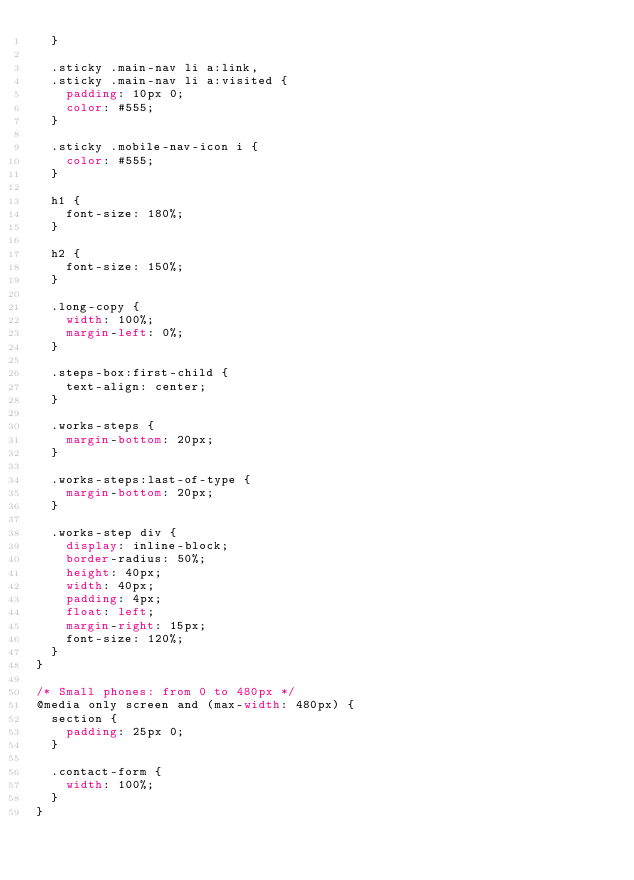<code> <loc_0><loc_0><loc_500><loc_500><_CSS_>  }

  .sticky .main-nav li a:link,
  .sticky .main-nav li a:visited {
    padding: 10px 0;
    color: #555;
  }

  .sticky .mobile-nav-icon i {
    color: #555;
  }

  h1 {
    font-size: 180%;
  }

  h2 {
    font-size: 150%;
  }

  .long-copy {
    width: 100%;
    margin-left: 0%;
  }

  .steps-box:first-child {
    text-align: center;
  }

  .works-steps {
    margin-bottom: 20px;
  }

  .works-steps:last-of-type {
    margin-bottom: 20px;
  }

  .works-step div {
    display: inline-block;
    border-radius: 50%;
    height: 40px;
    width: 40px;
    padding: 4px;
    float: left;
    margin-right: 15px;
    font-size: 120%;
  }
}

/* Small phones: from 0 to 480px */
@media only screen and (max-width: 480px) {
  section {
    padding: 25px 0;
  }

  .contact-form {
    width: 100%;
  }
}
</code> 